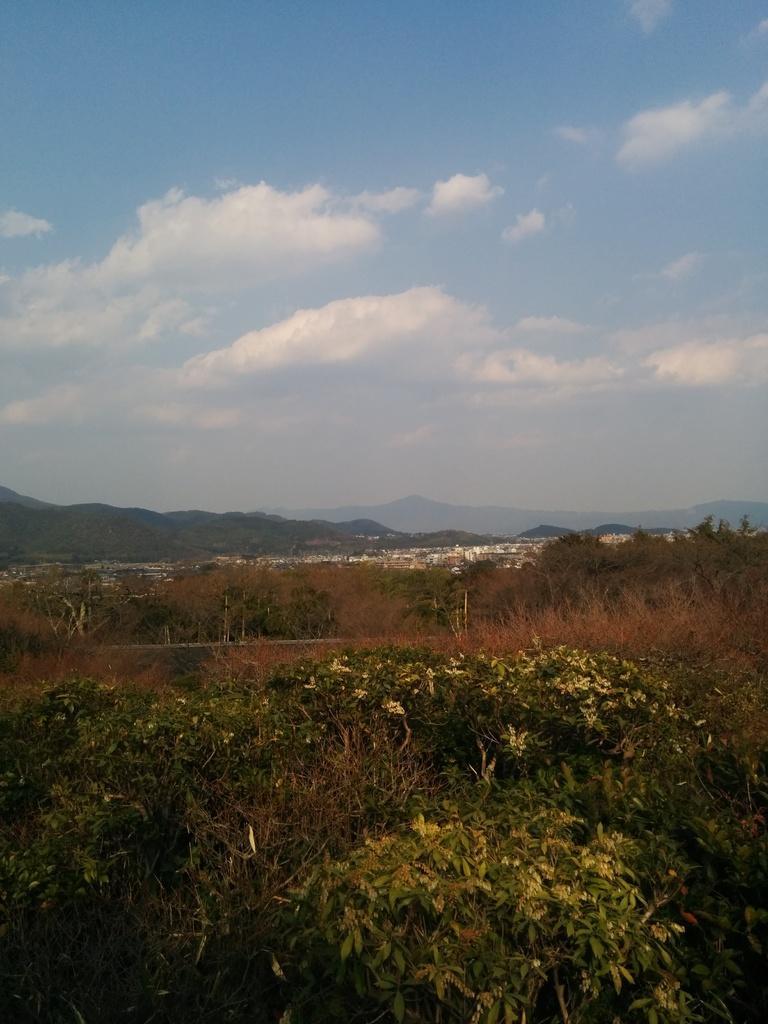Describe this image in one or two sentences. This image is taken outdoors. At the top of the image there is the sky with clouds. In the background there are a few hills. At the bottom of the image there are many trees and plants on the ground. 